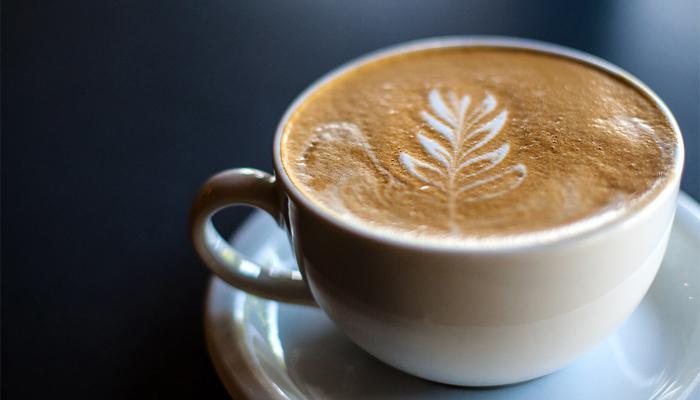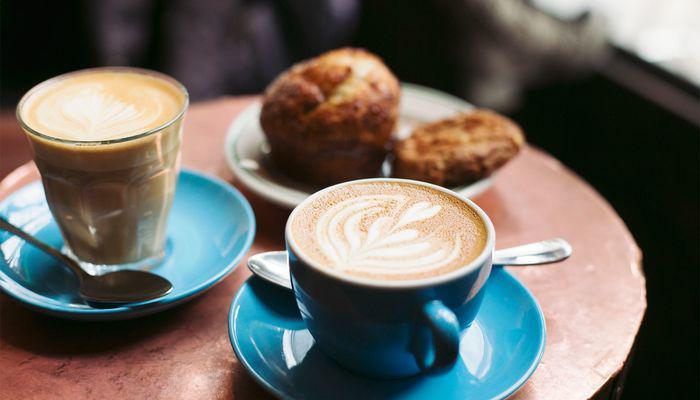The first image is the image on the left, the second image is the image on the right. Analyze the images presented: Is the assertion "All cups have patterns created by swirls of cream in a brown beverage showing at their tops." valid? Answer yes or no. Yes. 